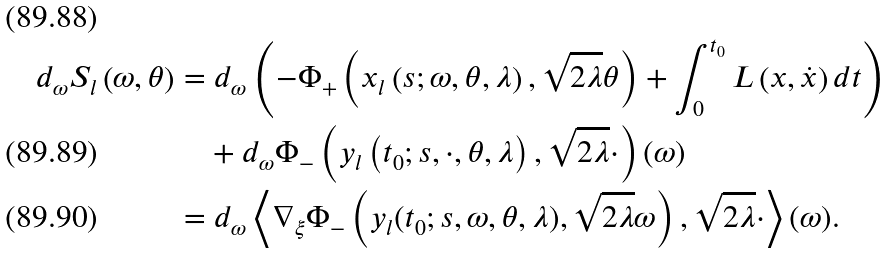<formula> <loc_0><loc_0><loc_500><loc_500>d _ { \omega } S _ { l } \left ( \omega , \theta \right ) & = d _ { \omega } \left ( - \Phi _ { + } \left ( x _ { l } \left ( s ; \omega , \theta , \lambda \right ) , \sqrt { 2 \lambda } \theta \right ) + \int _ { 0 } ^ { t _ { 0 } } L \left ( x , \dot { x } \right ) d t \right ) \\ & \quad + d _ { \omega } \Phi _ { - } \left ( y _ { l } \left ( t _ { 0 } ; s , \cdot , \theta , \lambda \right ) , \sqrt { 2 \lambda } \cdot \right ) ( \omega ) \\ & = d _ { \omega } \left \langle \nabla _ { \xi } \Phi _ { - } \left ( y _ { l } ( t _ { 0 } ; s , \omega , \theta , \lambda ) , \sqrt { 2 \lambda } \omega \right ) , \sqrt { 2 \lambda } \cdot \right \rangle ( \omega ) .</formula> 